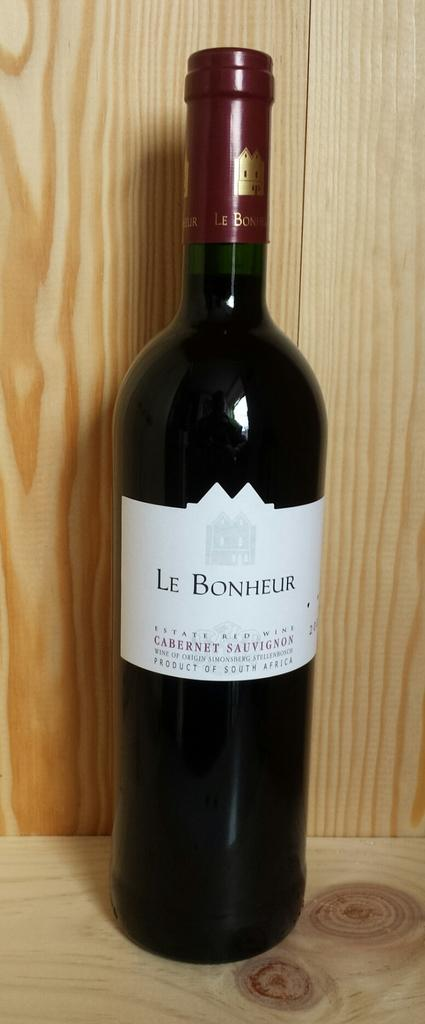<image>
Give a short and clear explanation of the subsequent image. A bottle of Le Bonheur wine sits on a wood shelf in front of a wooden wall. 